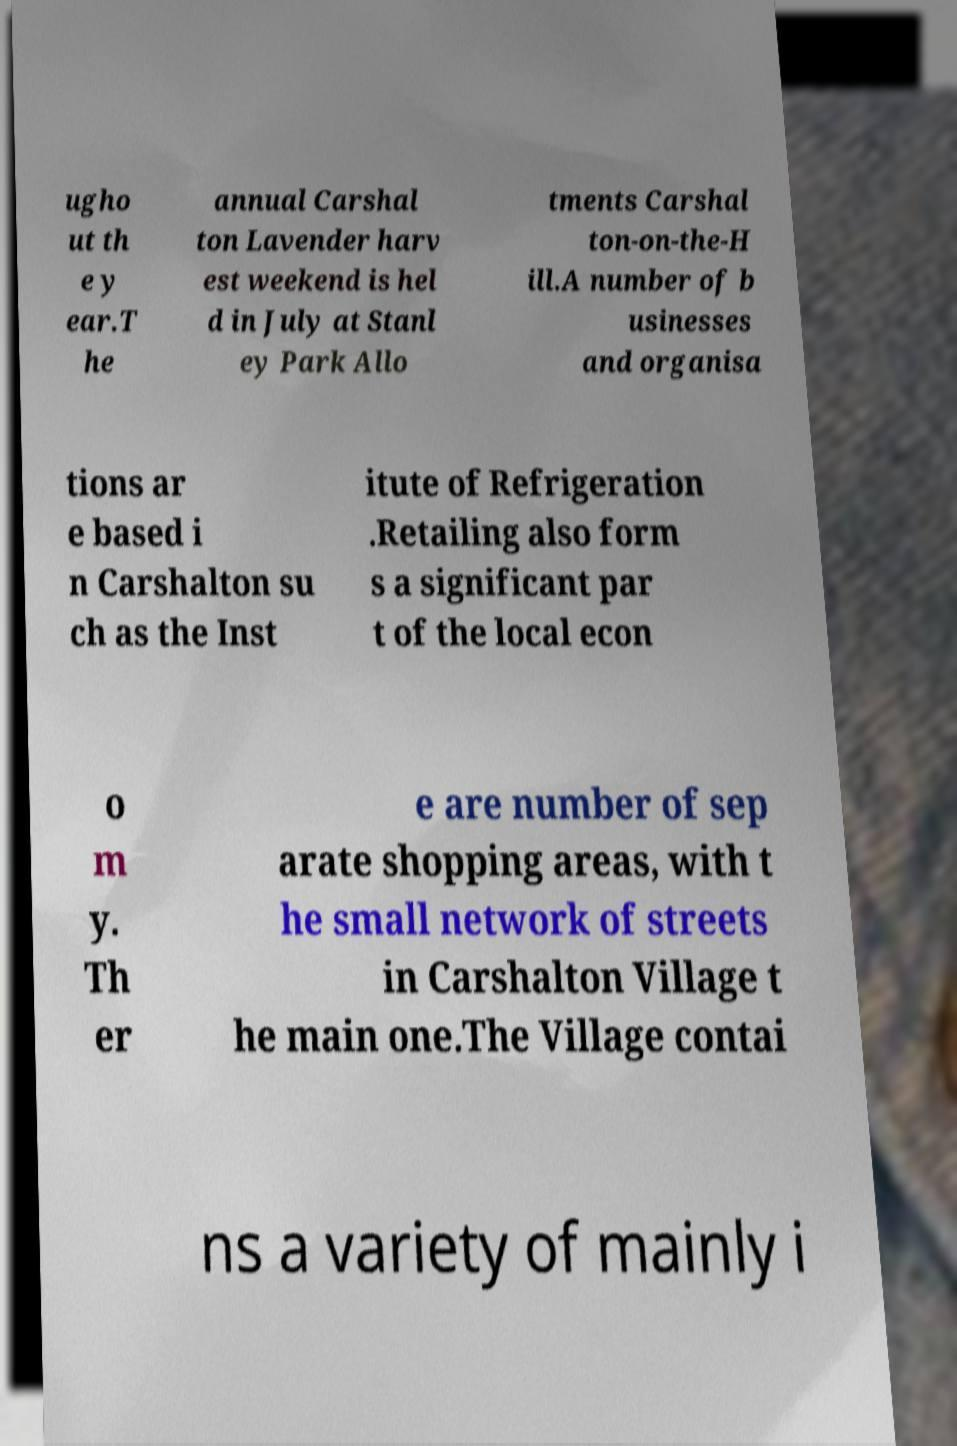Can you accurately transcribe the text from the provided image for me? ugho ut th e y ear.T he annual Carshal ton Lavender harv est weekend is hel d in July at Stanl ey Park Allo tments Carshal ton-on-the-H ill.A number of b usinesses and organisa tions ar e based i n Carshalton su ch as the Inst itute of Refrigeration .Retailing also form s a significant par t of the local econ o m y. Th er e are number of sep arate shopping areas, with t he small network of streets in Carshalton Village t he main one.The Village contai ns a variety of mainly i 